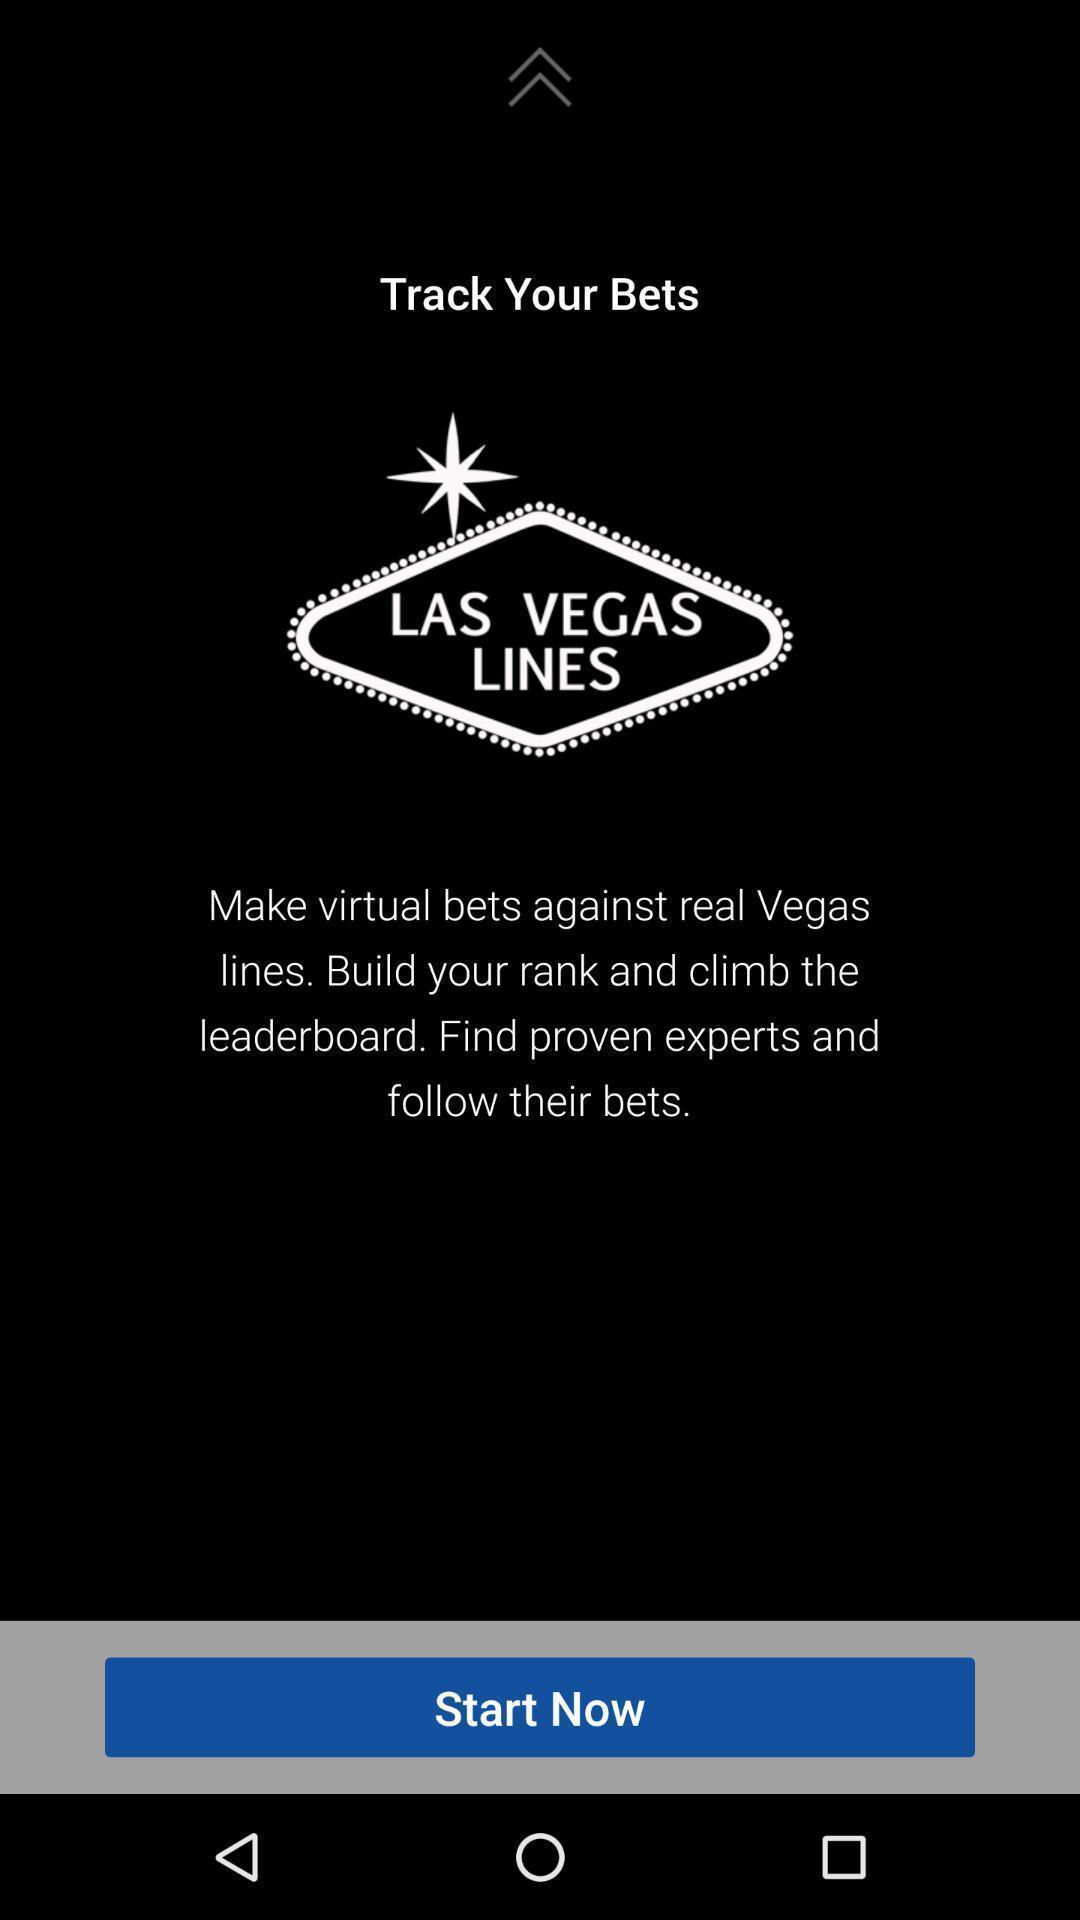Summarize the main components in this picture. Start page. 